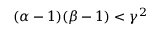<formula> <loc_0><loc_0><loc_500><loc_500>( \alpha - 1 ) ( \beta - 1 ) < \gamma ^ { 2 }</formula> 